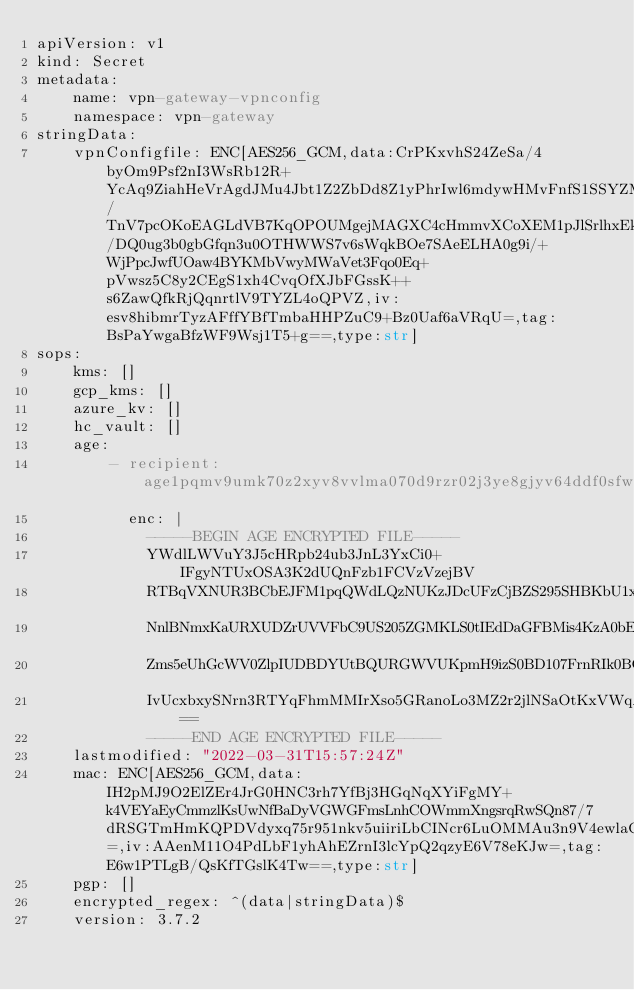<code> <loc_0><loc_0><loc_500><loc_500><_YAML_>apiVersion: v1
kind: Secret
metadata:
    name: vpn-gateway-vpnconfig
    namespace: vpn-gateway
stringData:
    vpnConfigfile: ENC[AES256_GCM,data:CrPKxvhS24ZeSa/4byOm9Psf2nI3WsRb12R+YcAq9ZiahHeVrAgdJMu4Jbt1Z2ZbDd8Z1yPhrIwl6mdywHMvFnfS1SSYZMfHxI1xwYz455lBxz2NoYE5ZumshkNgF3gXEmu2x/TnV7pcOKoEAGLdVB7KqOPOUMgejMAGXC4cHmmvXCoXEM1pJlSrlhxEkhZ4Za6hfgR59Or4z1j4Ui9DNtXF5w8A/DQ0ug3b0gbGfqn3u0OTHWWS7v6sWqkBOe7SAeELHA0g9i/+WjPpcJwfUOaw4BYKMbVwyMWaVet3Fqo0Eq+pVwsz5C8y2CEgS1xh4CvqOfXJbFGssK++s6ZawQfkRjQqnrtlV9TYZL4oQPVZ,iv:esv8hibmrTyzAFffYBfTmbaHHPZuC9+Bz0Uaf6aVRqU=,tag:BsPaYwgaBfzWF9Wsj1T5+g==,type:str]
sops:
    kms: []
    gcp_kms: []
    azure_kv: []
    hc_vault: []
    age:
        - recipient: age1pqmv9umk70z2xyv8vvlma070d9rzr02j3ye8gjyv64ddf0sfwccspwsj8d
          enc: |
            -----BEGIN AGE ENCRYPTED FILE-----
            YWdlLWVuY3J5cHRpb24ub3JnL3YxCi0+IFgyNTUxOSA3K2dUQnFzb1FCVzVzejBV
            RTBqVXNUR3BCbEJFM1pqQWdLQzNUKzJDcUFzCjBZS295SHBKbU1xT213RVZzVjg3
            NnlBNmxKaURXUDZrUVVFbC9US205ZGMKLS0tIEdDaGFBMis4KzA0bEhsOXg5WWNE
            Zms5eUhGcWV0ZlpIUDBDYUtBQURGWVUKpmH9izS0BD107FrnRIk0BCsvOfWuMQrN
            IvUcxbxySNrn3RTYqFhmMMIrXso5GRanoLo3MZ2r2jlNSaOtKxVWqA==
            -----END AGE ENCRYPTED FILE-----
    lastmodified: "2022-03-31T15:57:24Z"
    mac: ENC[AES256_GCM,data:IH2pMJ9O2ElZEr4JrG0HNC3rh7YfBj3HGqNqXYiFgMY+k4VEYaEyCmmzlKsUwNfBaDyVGWGFmsLnhCOWmmXngsrqRwSQn87/7dRSGTmHmKQPDVdyxq75r951nkv5uiiriLbCINcr6LuOMMAu3n9V4ewlaCkfh7APnh4ZkpzJBac=,iv:AAenM11O4PdLbF1yhAhEZrnI3lcYpQ2qzyE6V78eKJw=,tag:E6w1PTLgB/QsKfTGslK4Tw==,type:str]
    pgp: []
    encrypted_regex: ^(data|stringData)$
    version: 3.7.2
</code> 